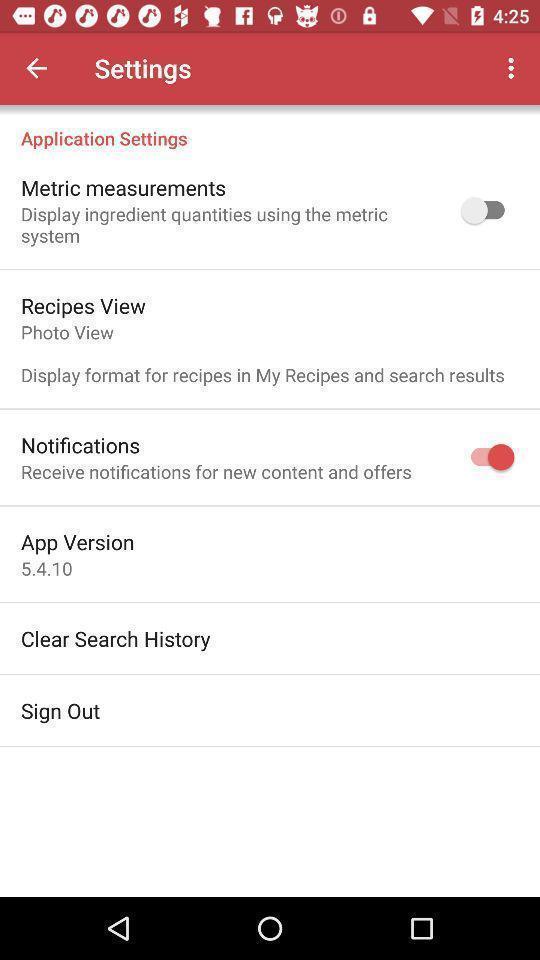What is the overall content of this screenshot? Screen displaying list of settings on recipes app. 